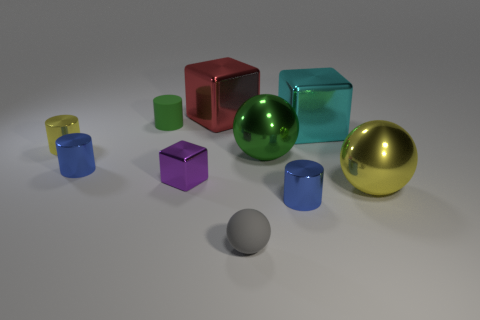Can you speculate on the purpose of this arrangement of objects? This arrangement of objects may have been designed for a visual study or to serve as a reference for reflections, lighting, and shadows in an artistic or graphical context. It might also be used to demonstrate the shapes and colors of objects in a learning environment. Do you think this image might have a practical application? Yes, images like these can be quite useful in computer graphics to test rendering techniques, study the play of light on different surfaces, or as part of a portfolio showcasing modeling skills. They can also help in teaching about geometric shapes and the properties of light and color. 